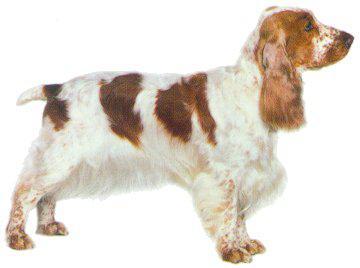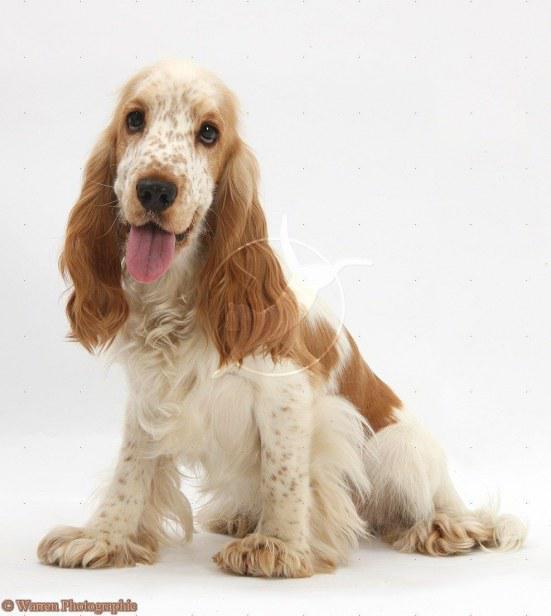The first image is the image on the left, the second image is the image on the right. Given the left and right images, does the statement "At least one of the images shows a Cocker Spaniel with their tongue out." hold true? Answer yes or no. Yes. The first image is the image on the left, the second image is the image on the right. Considering the images on both sides, is "The combined images include one dog reclining with front paws extended and one dog with red-orange fur sitting upright." valid? Answer yes or no. No. 